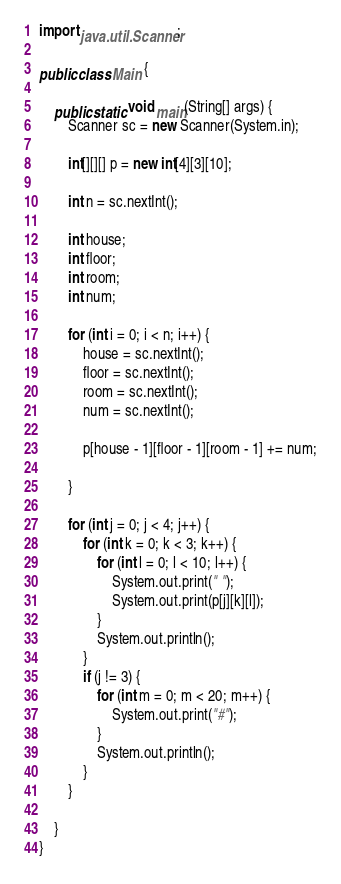<code> <loc_0><loc_0><loc_500><loc_500><_Java_>import java.util.Scanner;

public class Main {

	public static void main(String[] args) {
		Scanner sc = new Scanner(System.in);

		int[][][] p = new int[4][3][10];

		int n = sc.nextInt();

		int house;
		int floor;
		int room;
		int num;

		for (int i = 0; i < n; i++) {
			house = sc.nextInt();
			floor = sc.nextInt();
			room = sc.nextInt();
			num = sc.nextInt();

			p[house - 1][floor - 1][room - 1] += num;
			
		}

		for (int j = 0; j < 4; j++) {
			for (int k = 0; k < 3; k++) {
				for (int l = 0; l < 10; l++) {
					System.out.print(" ");
					System.out.print(p[j][k][l]);
				}
				System.out.println();
			}
			if (j != 3) {
				for (int m = 0; m < 20; m++) {
					System.out.print("#");
				}
				System.out.println();
			}
		}

	}
}
</code> 